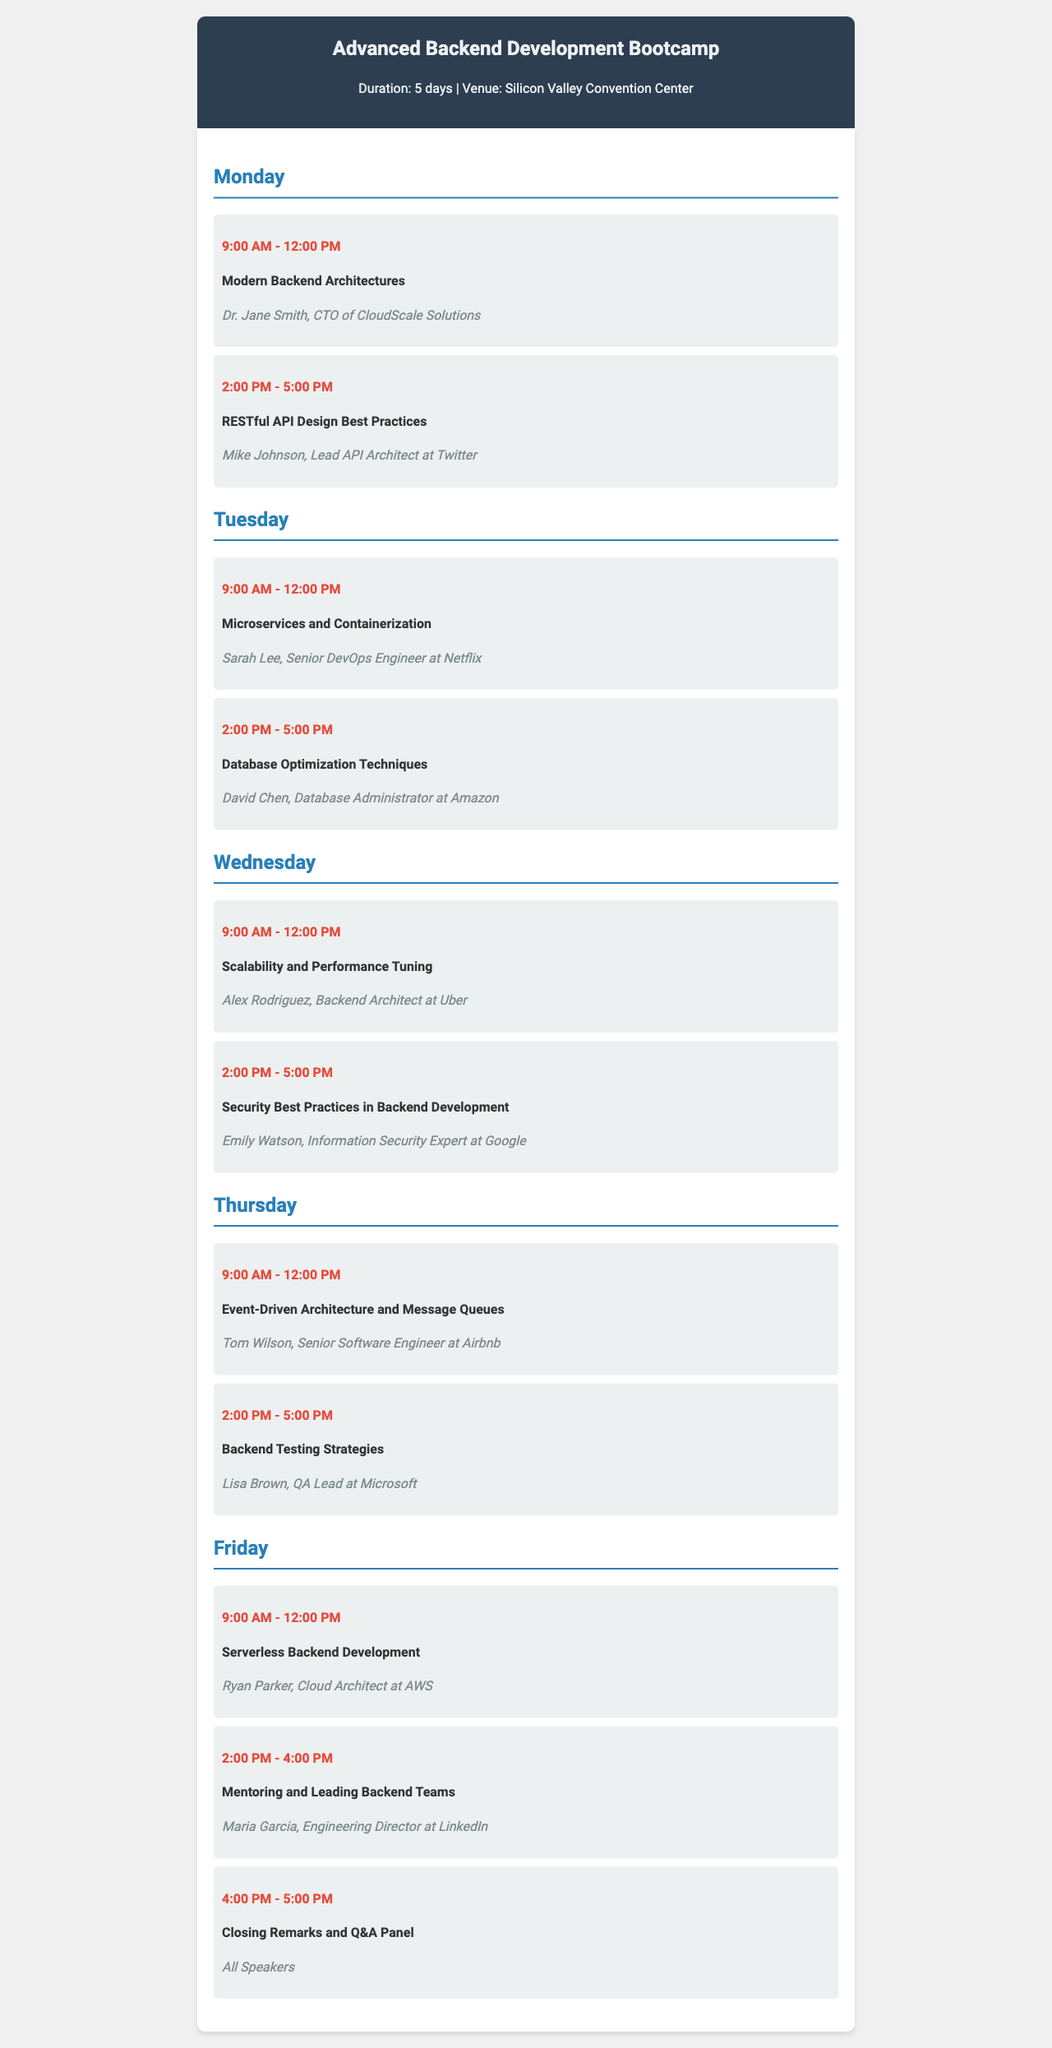What is the venue for the bootcamp? The venue is mentioned in the header section of the document.
Answer: Silicon Valley Convention Center Who is the speaker for the session on RESTful API Design Best Practices? The speaker's name is listed under the session topic for RESTful API Design Best Practices.
Answer: Mike Johnson What session is scheduled at 9:00 AM on Wednesday? This can be found by looking at the schedule for Wednesday and the session time.
Answer: Scalability and Performance Tuning How many sessions are there on Friday? This is determined by counting the sessions listed for Friday in the schedule.
Answer: Three Who is speaking about Backend Testing Strategies? The speaker's name is found under the session topic for Backend Testing Strategies on Thursday.
Answer: Lisa Brown What topic is covered right before the Closing Remarks and Q&A Panel? The session directly preceding the Closing Remarks and Q&A Panel can be found in the Friday schedule.
Answer: Mentoring and Leading Backend Teams What day is dedicated to Microservices and Containerization? This can be answered by checking the scheduled topics on different days of the week.
Answer: Tuesday What time does the session on Security Best Practices in Backend Development start? The start time is listed with the session topic on Wednesday.
Answer: 2:00 PM 